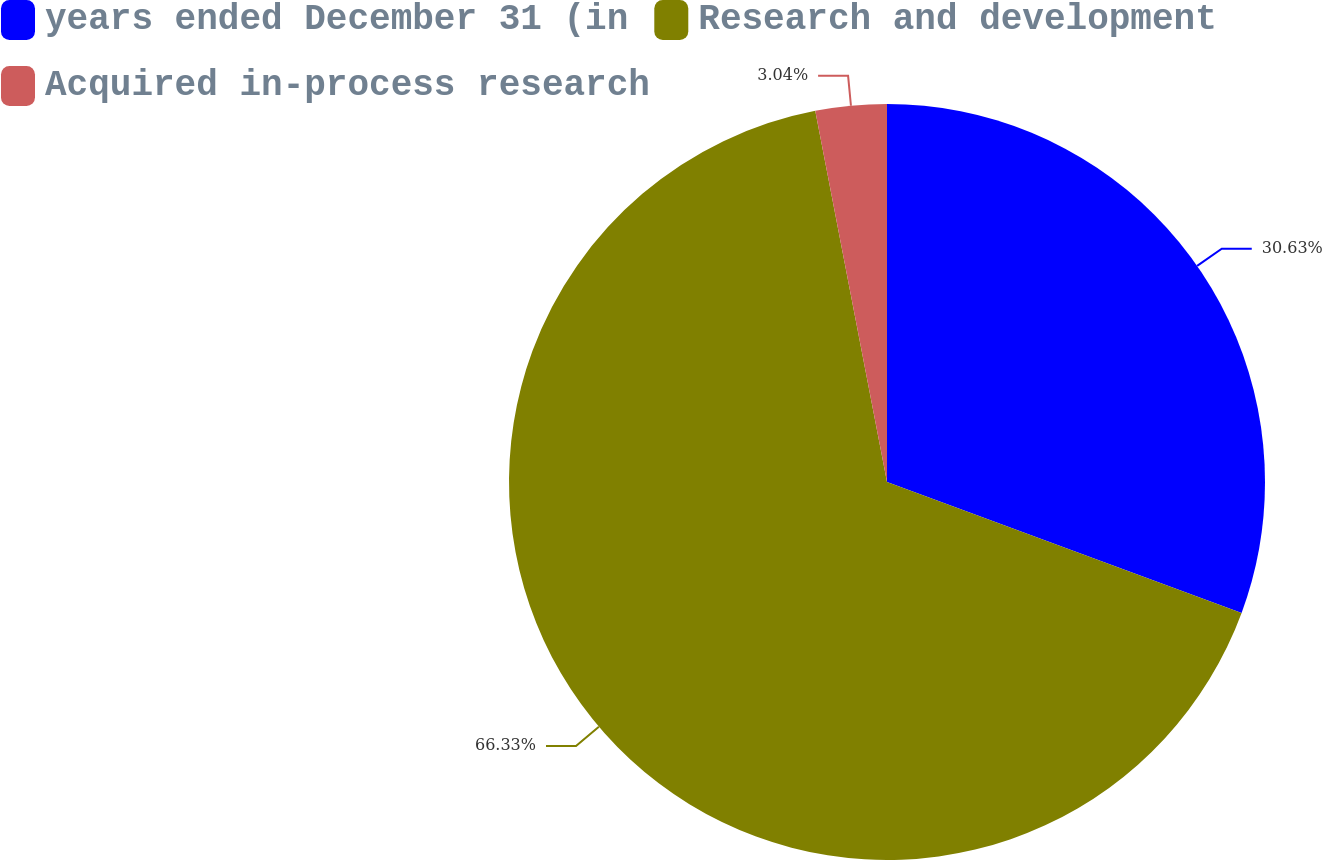Convert chart to OTSL. <chart><loc_0><loc_0><loc_500><loc_500><pie_chart><fcel>years ended December 31 (in<fcel>Research and development<fcel>Acquired in-process research<nl><fcel>30.63%<fcel>66.33%<fcel>3.04%<nl></chart> 